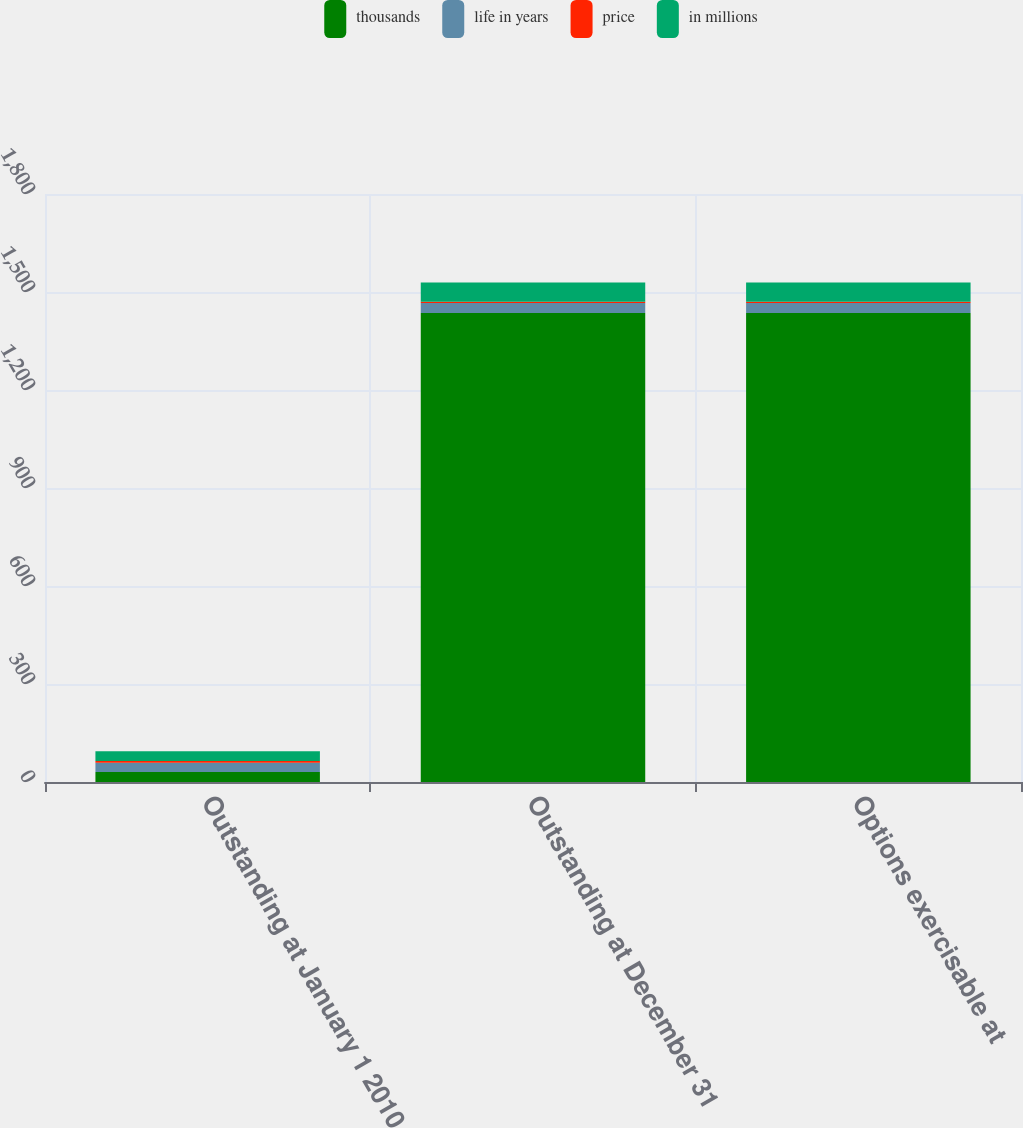<chart> <loc_0><loc_0><loc_500><loc_500><stacked_bar_chart><ecel><fcel>Outstanding at January 1 2010<fcel>Outstanding at December 31<fcel>Options exercisable at<nl><fcel>thousands<fcel>30.65<fcel>1436<fcel>1436<nl><fcel>life in years<fcel>27.98<fcel>30.65<fcel>30.65<nl><fcel>price<fcel>5.8<fcel>3.4<fcel>3.4<nl><fcel>in millions<fcel>29.7<fcel>58.8<fcel>58.8<nl></chart> 